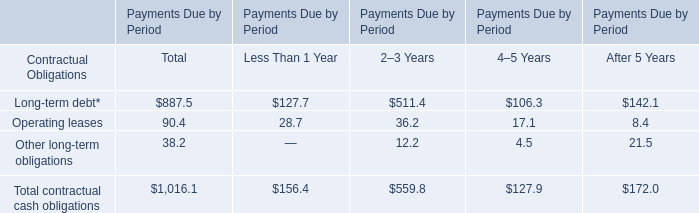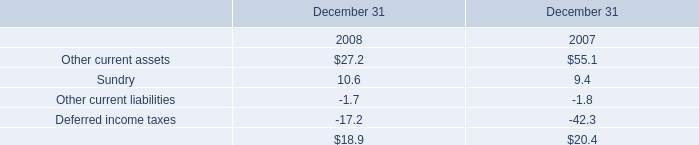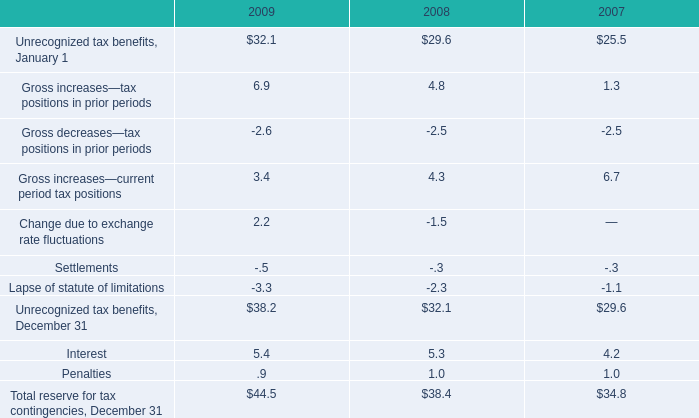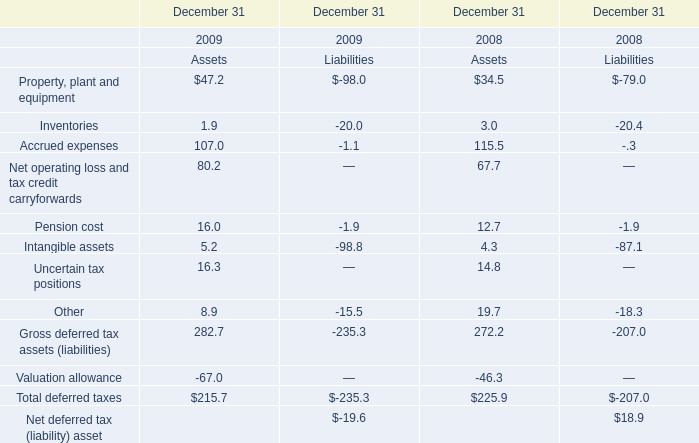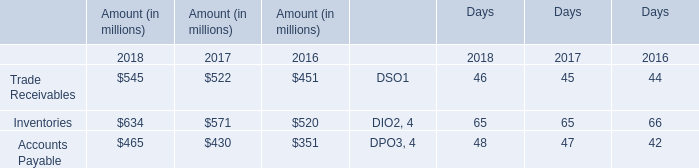What do all Assets sum up, excluding those negative ones in 2009? 
Computations: (282.7 + 215.7)
Answer: 498.4. 